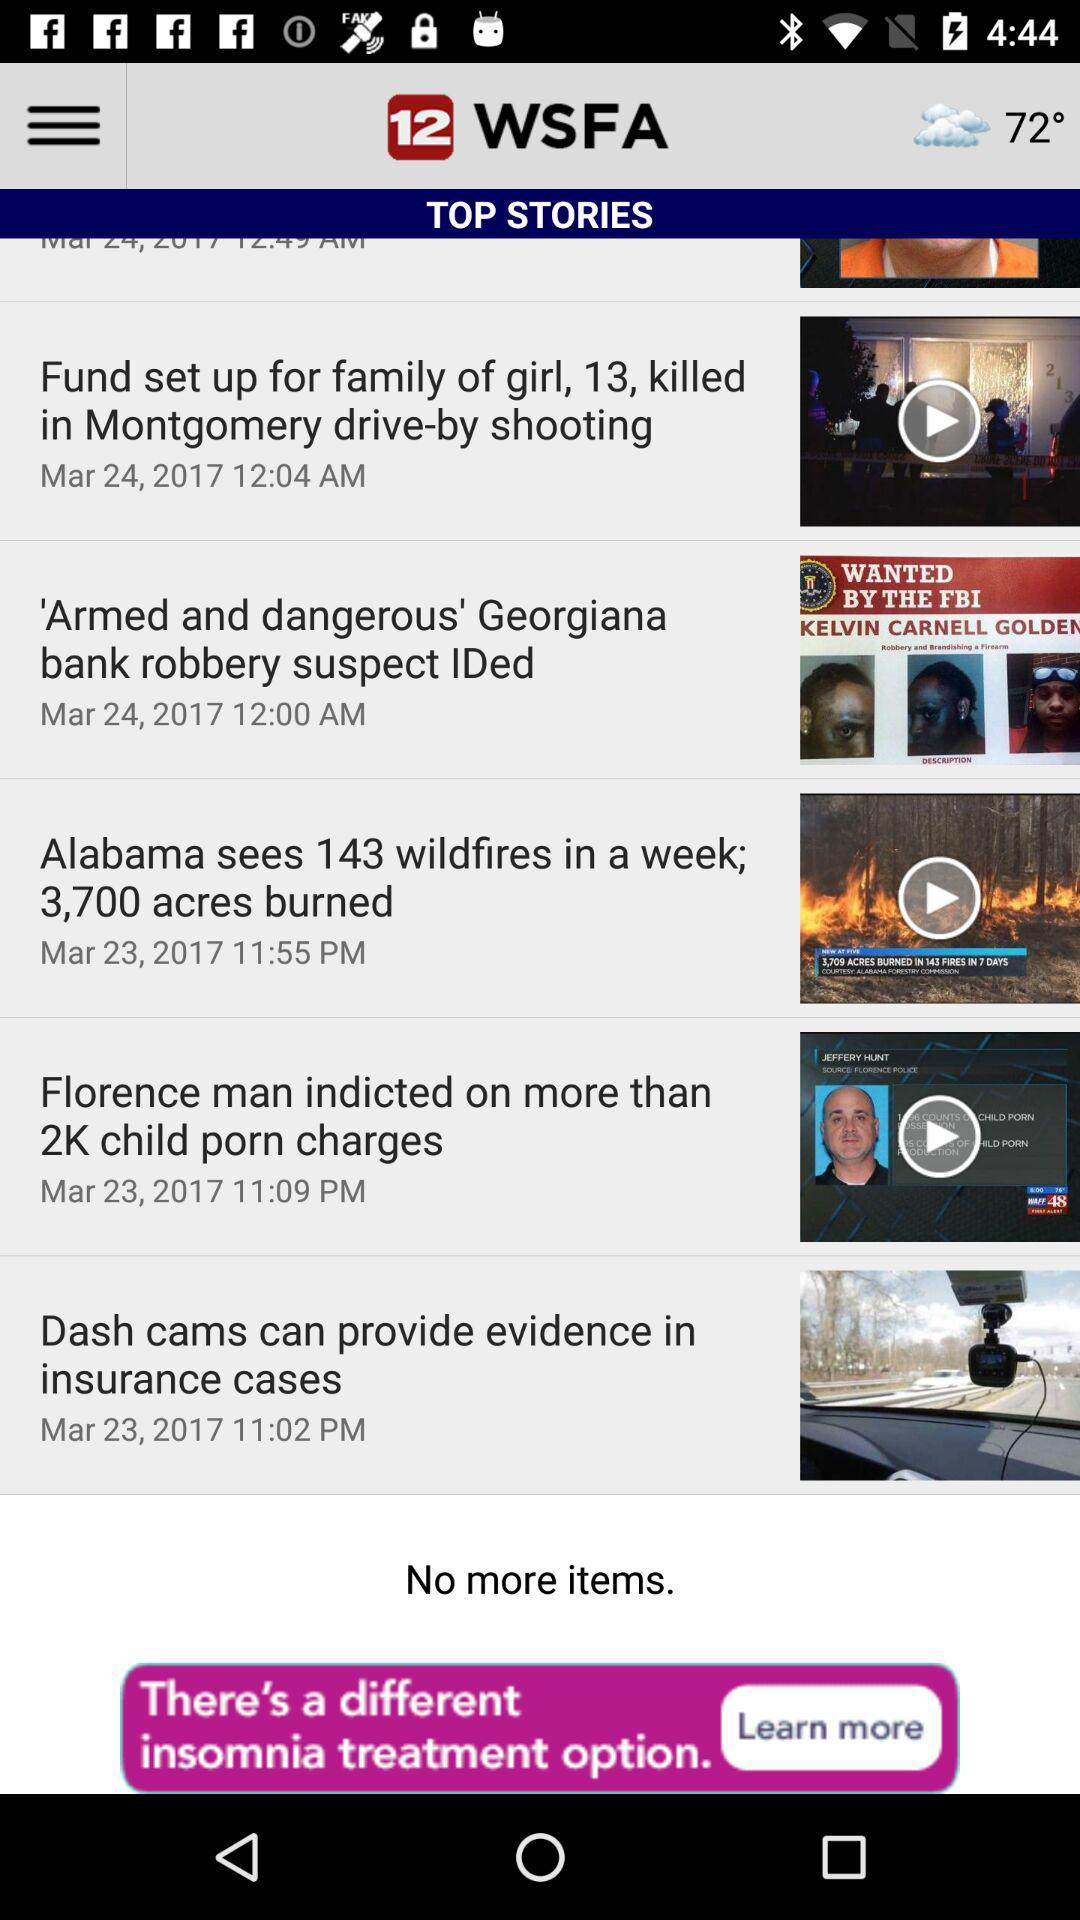When was the article "Armed and dangerous" published? The article was published on March 24, 2017 at 12:00 a.m. 